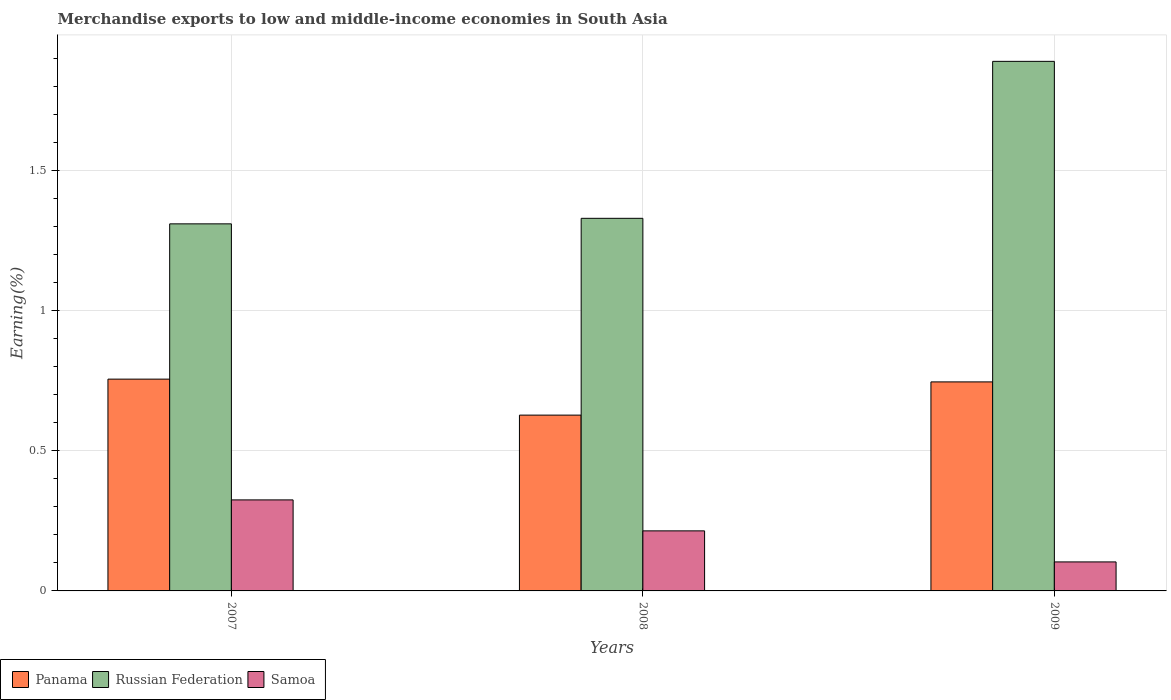How many different coloured bars are there?
Offer a terse response. 3. How many bars are there on the 3rd tick from the left?
Keep it short and to the point. 3. In how many cases, is the number of bars for a given year not equal to the number of legend labels?
Offer a terse response. 0. What is the percentage of amount earned from merchandise exports in Samoa in 2009?
Ensure brevity in your answer.  0.1. Across all years, what is the maximum percentage of amount earned from merchandise exports in Panama?
Your answer should be compact. 0.76. Across all years, what is the minimum percentage of amount earned from merchandise exports in Russian Federation?
Your answer should be compact. 1.31. In which year was the percentage of amount earned from merchandise exports in Samoa maximum?
Your response must be concise. 2007. What is the total percentage of amount earned from merchandise exports in Samoa in the graph?
Your answer should be compact. 0.64. What is the difference between the percentage of amount earned from merchandise exports in Russian Federation in 2008 and that in 2009?
Keep it short and to the point. -0.56. What is the difference between the percentage of amount earned from merchandise exports in Russian Federation in 2007 and the percentage of amount earned from merchandise exports in Samoa in 2009?
Keep it short and to the point. 1.21. What is the average percentage of amount earned from merchandise exports in Panama per year?
Offer a very short reply. 0.71. In the year 2009, what is the difference between the percentage of amount earned from merchandise exports in Russian Federation and percentage of amount earned from merchandise exports in Samoa?
Give a very brief answer. 1.79. What is the ratio of the percentage of amount earned from merchandise exports in Samoa in 2007 to that in 2008?
Make the answer very short. 1.52. Is the difference between the percentage of amount earned from merchandise exports in Russian Federation in 2007 and 2009 greater than the difference between the percentage of amount earned from merchandise exports in Samoa in 2007 and 2009?
Make the answer very short. No. What is the difference between the highest and the second highest percentage of amount earned from merchandise exports in Panama?
Offer a very short reply. 0.01. What is the difference between the highest and the lowest percentage of amount earned from merchandise exports in Samoa?
Your answer should be very brief. 0.22. In how many years, is the percentage of amount earned from merchandise exports in Samoa greater than the average percentage of amount earned from merchandise exports in Samoa taken over all years?
Provide a succinct answer. 2. Is the sum of the percentage of amount earned from merchandise exports in Panama in 2007 and 2008 greater than the maximum percentage of amount earned from merchandise exports in Samoa across all years?
Your answer should be compact. Yes. What does the 1st bar from the left in 2007 represents?
Your answer should be very brief. Panama. What does the 2nd bar from the right in 2009 represents?
Ensure brevity in your answer.  Russian Federation. How many years are there in the graph?
Provide a short and direct response. 3. What is the difference between two consecutive major ticks on the Y-axis?
Ensure brevity in your answer.  0.5. Does the graph contain grids?
Provide a short and direct response. Yes. How many legend labels are there?
Provide a succinct answer. 3. How are the legend labels stacked?
Ensure brevity in your answer.  Horizontal. What is the title of the graph?
Provide a succinct answer. Merchandise exports to low and middle-income economies in South Asia. What is the label or title of the Y-axis?
Your answer should be very brief. Earning(%). What is the Earning(%) of Panama in 2007?
Make the answer very short. 0.76. What is the Earning(%) of Russian Federation in 2007?
Provide a short and direct response. 1.31. What is the Earning(%) of Samoa in 2007?
Your response must be concise. 0.32. What is the Earning(%) of Panama in 2008?
Keep it short and to the point. 0.63. What is the Earning(%) of Russian Federation in 2008?
Your response must be concise. 1.33. What is the Earning(%) in Samoa in 2008?
Ensure brevity in your answer.  0.21. What is the Earning(%) in Panama in 2009?
Give a very brief answer. 0.75. What is the Earning(%) of Russian Federation in 2009?
Provide a short and direct response. 1.89. What is the Earning(%) in Samoa in 2009?
Your response must be concise. 0.1. Across all years, what is the maximum Earning(%) in Panama?
Provide a succinct answer. 0.76. Across all years, what is the maximum Earning(%) of Russian Federation?
Provide a short and direct response. 1.89. Across all years, what is the maximum Earning(%) in Samoa?
Keep it short and to the point. 0.32. Across all years, what is the minimum Earning(%) in Panama?
Give a very brief answer. 0.63. Across all years, what is the minimum Earning(%) in Russian Federation?
Your response must be concise. 1.31. Across all years, what is the minimum Earning(%) in Samoa?
Make the answer very short. 0.1. What is the total Earning(%) of Panama in the graph?
Your response must be concise. 2.13. What is the total Earning(%) of Russian Federation in the graph?
Make the answer very short. 4.53. What is the total Earning(%) in Samoa in the graph?
Offer a terse response. 0.64. What is the difference between the Earning(%) in Panama in 2007 and that in 2008?
Your answer should be very brief. 0.13. What is the difference between the Earning(%) of Russian Federation in 2007 and that in 2008?
Make the answer very short. -0.02. What is the difference between the Earning(%) in Samoa in 2007 and that in 2008?
Offer a very short reply. 0.11. What is the difference between the Earning(%) in Panama in 2007 and that in 2009?
Your answer should be very brief. 0.01. What is the difference between the Earning(%) of Russian Federation in 2007 and that in 2009?
Your answer should be very brief. -0.58. What is the difference between the Earning(%) of Samoa in 2007 and that in 2009?
Ensure brevity in your answer.  0.22. What is the difference between the Earning(%) of Panama in 2008 and that in 2009?
Your answer should be compact. -0.12. What is the difference between the Earning(%) of Russian Federation in 2008 and that in 2009?
Your response must be concise. -0.56. What is the difference between the Earning(%) of Samoa in 2008 and that in 2009?
Offer a very short reply. 0.11. What is the difference between the Earning(%) of Panama in 2007 and the Earning(%) of Russian Federation in 2008?
Ensure brevity in your answer.  -0.57. What is the difference between the Earning(%) in Panama in 2007 and the Earning(%) in Samoa in 2008?
Offer a very short reply. 0.54. What is the difference between the Earning(%) of Russian Federation in 2007 and the Earning(%) of Samoa in 2008?
Give a very brief answer. 1.1. What is the difference between the Earning(%) of Panama in 2007 and the Earning(%) of Russian Federation in 2009?
Your answer should be compact. -1.13. What is the difference between the Earning(%) of Panama in 2007 and the Earning(%) of Samoa in 2009?
Offer a very short reply. 0.65. What is the difference between the Earning(%) of Russian Federation in 2007 and the Earning(%) of Samoa in 2009?
Keep it short and to the point. 1.21. What is the difference between the Earning(%) in Panama in 2008 and the Earning(%) in Russian Federation in 2009?
Your answer should be compact. -1.26. What is the difference between the Earning(%) of Panama in 2008 and the Earning(%) of Samoa in 2009?
Offer a terse response. 0.52. What is the difference between the Earning(%) in Russian Federation in 2008 and the Earning(%) in Samoa in 2009?
Provide a short and direct response. 1.23. What is the average Earning(%) in Panama per year?
Keep it short and to the point. 0.71. What is the average Earning(%) in Russian Federation per year?
Offer a terse response. 1.51. What is the average Earning(%) of Samoa per year?
Give a very brief answer. 0.21. In the year 2007, what is the difference between the Earning(%) in Panama and Earning(%) in Russian Federation?
Your answer should be compact. -0.55. In the year 2007, what is the difference between the Earning(%) in Panama and Earning(%) in Samoa?
Give a very brief answer. 0.43. In the year 2007, what is the difference between the Earning(%) of Russian Federation and Earning(%) of Samoa?
Give a very brief answer. 0.98. In the year 2008, what is the difference between the Earning(%) of Panama and Earning(%) of Russian Federation?
Your answer should be compact. -0.7. In the year 2008, what is the difference between the Earning(%) in Panama and Earning(%) in Samoa?
Make the answer very short. 0.41. In the year 2008, what is the difference between the Earning(%) in Russian Federation and Earning(%) in Samoa?
Give a very brief answer. 1.11. In the year 2009, what is the difference between the Earning(%) of Panama and Earning(%) of Russian Federation?
Ensure brevity in your answer.  -1.14. In the year 2009, what is the difference between the Earning(%) of Panama and Earning(%) of Samoa?
Your response must be concise. 0.64. In the year 2009, what is the difference between the Earning(%) in Russian Federation and Earning(%) in Samoa?
Offer a very short reply. 1.79. What is the ratio of the Earning(%) of Panama in 2007 to that in 2008?
Offer a terse response. 1.2. What is the ratio of the Earning(%) of Russian Federation in 2007 to that in 2008?
Your answer should be compact. 0.99. What is the ratio of the Earning(%) of Samoa in 2007 to that in 2008?
Make the answer very short. 1.52. What is the ratio of the Earning(%) of Panama in 2007 to that in 2009?
Your response must be concise. 1.01. What is the ratio of the Earning(%) in Russian Federation in 2007 to that in 2009?
Provide a short and direct response. 0.69. What is the ratio of the Earning(%) of Samoa in 2007 to that in 2009?
Make the answer very short. 3.14. What is the ratio of the Earning(%) in Panama in 2008 to that in 2009?
Offer a very short reply. 0.84. What is the ratio of the Earning(%) in Russian Federation in 2008 to that in 2009?
Provide a short and direct response. 0.7. What is the ratio of the Earning(%) of Samoa in 2008 to that in 2009?
Your response must be concise. 2.07. What is the difference between the highest and the second highest Earning(%) of Panama?
Give a very brief answer. 0.01. What is the difference between the highest and the second highest Earning(%) of Russian Federation?
Offer a terse response. 0.56. What is the difference between the highest and the second highest Earning(%) of Samoa?
Make the answer very short. 0.11. What is the difference between the highest and the lowest Earning(%) of Panama?
Your response must be concise. 0.13. What is the difference between the highest and the lowest Earning(%) of Russian Federation?
Offer a terse response. 0.58. What is the difference between the highest and the lowest Earning(%) in Samoa?
Your response must be concise. 0.22. 